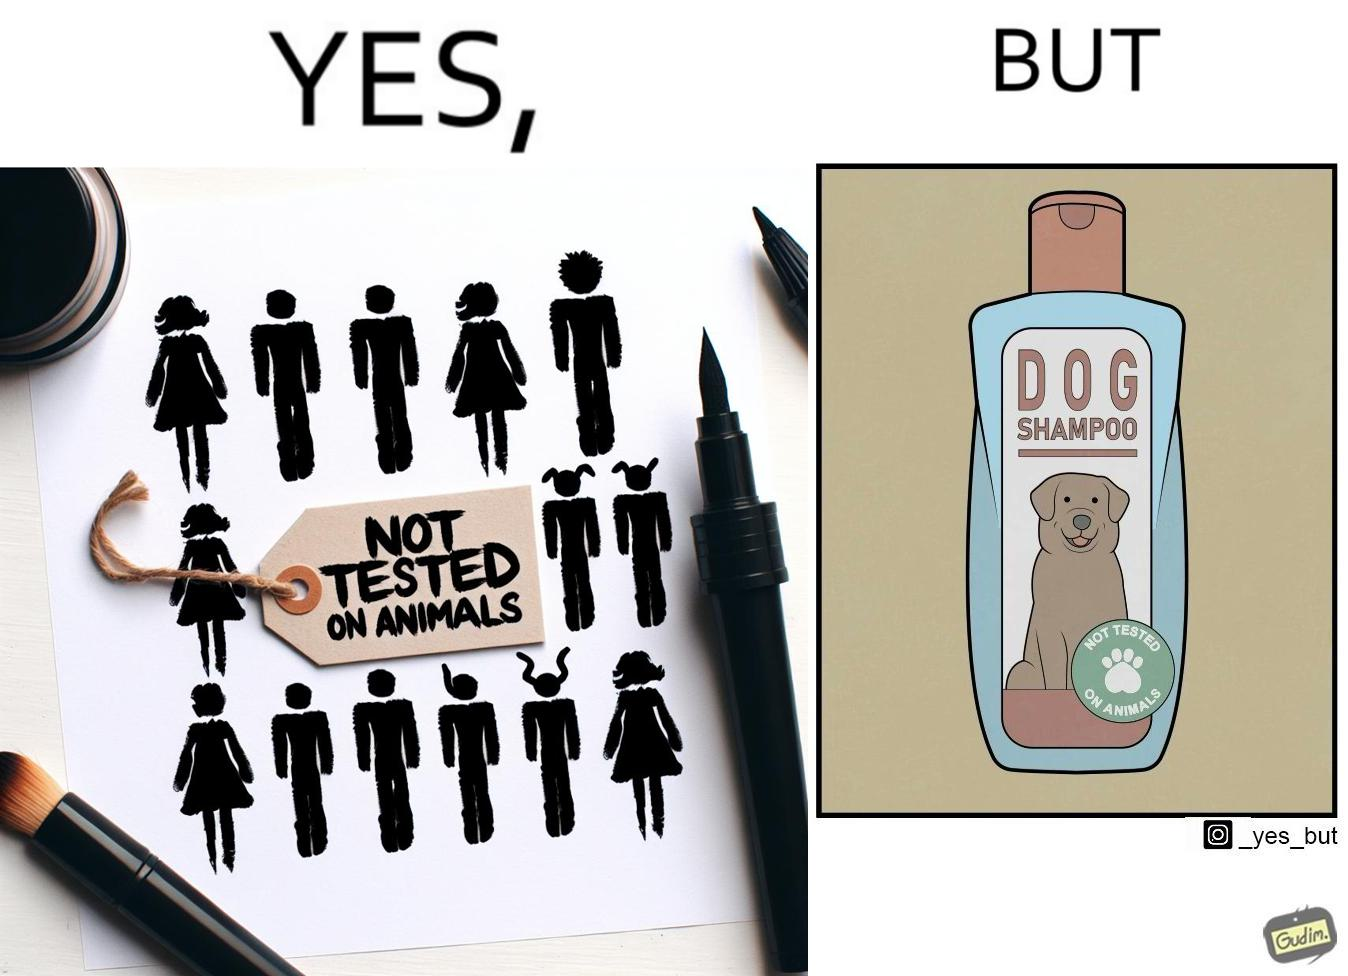Is there satirical content in this image? Yes, this image is satirical. 